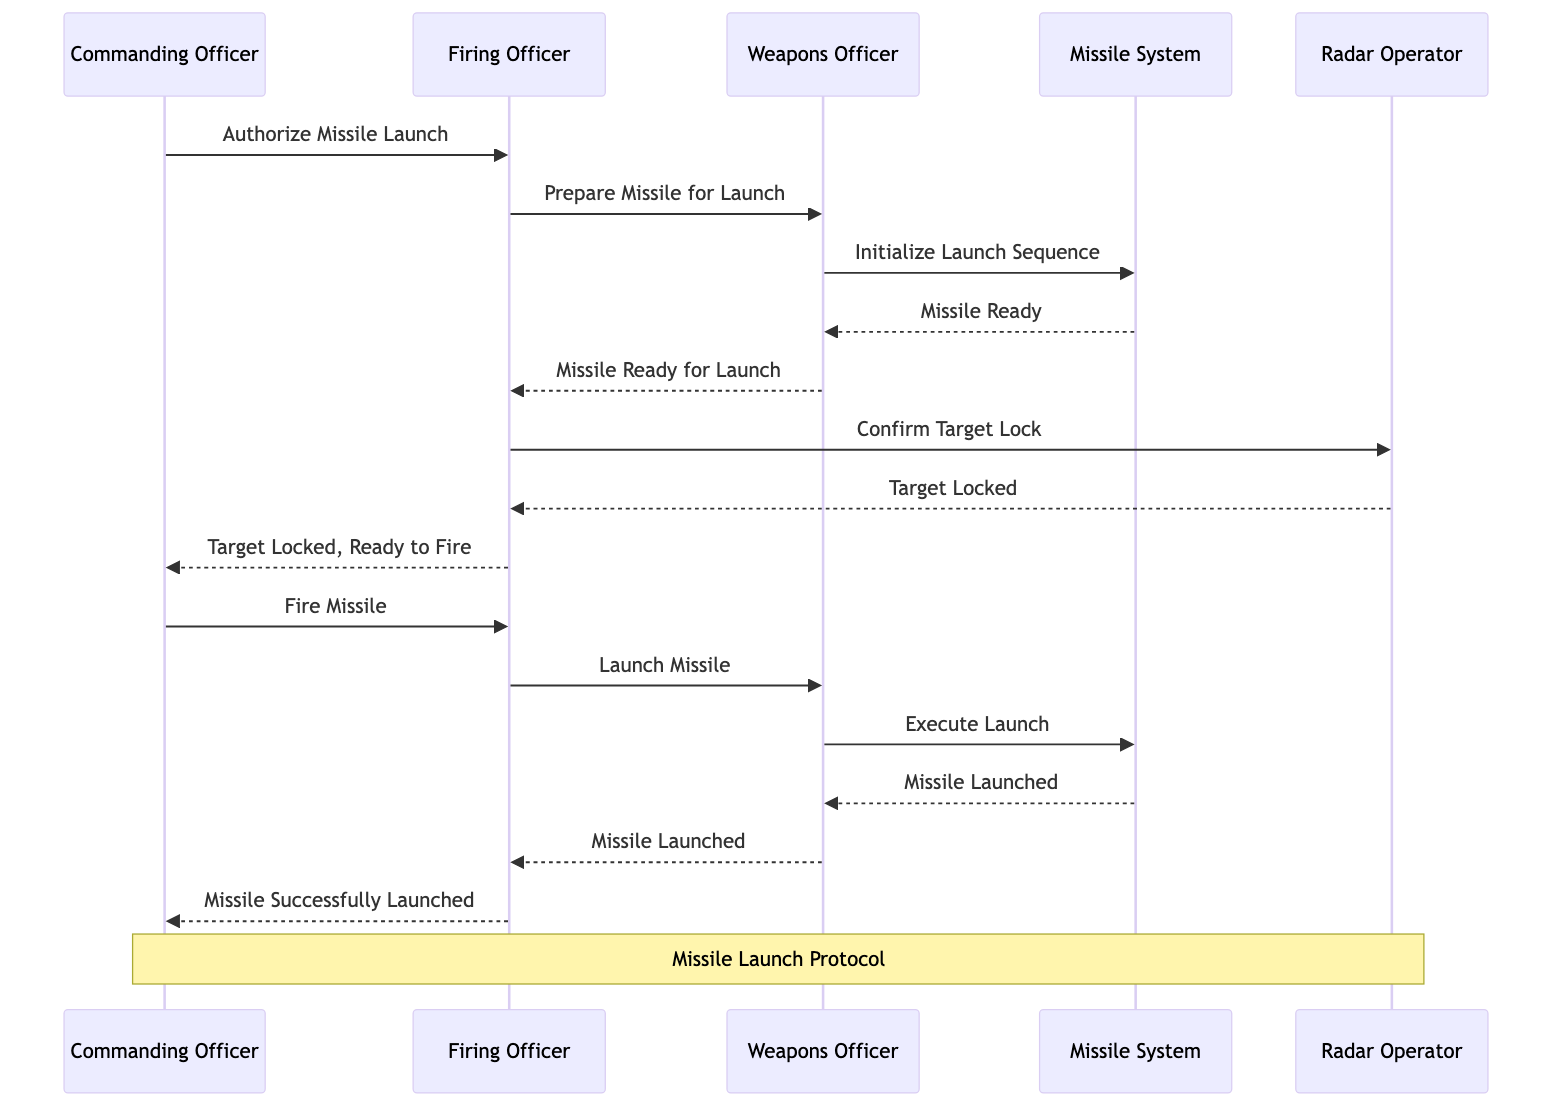What is the first command issued in the sequence? The sequence begins with the Commanding Officer issuing a command to the Firing Officer with the message "Authorize Missile Launch." This initiates the protocol.
Answer: Authorize Missile Launch How many officers are involved in the missile launch protocol? The diagram includes three officers: the Commanding Officer, the Firing Officer, and the Weapons Officer. Each has a distinct role in the launching process, making a total of three.
Answer: 3 Which actor confirms the target lock? The Firing Officer sends a signal to the Radar Operator to confirm the target lock. The Radar Operator responds back with "Target Locked." Thus, the Radar Operator is the one who confirms the target lock.
Answer: Radar Operator What message does the Firing Officer send after receiving confirmation of the target lock? After the target lock is confirmed, the Firing Officer notifies the Commanding Officer with the message "Target Locked, Ready to Fire." This indicates that the necessary steps have been completed for launching the missile.
Answer: Target Locked, Ready to Fire What happens immediately after the Firing Officer issues the command to launch the missile? The Firing Officer instructs the Weapons Officer to "Launch Missile," which is followed by the Weapons Officer signaling the Missile System to execute the launch. This means that the command initiates the launch sequence in the Missile System.
Answer: Execute Launch What is the final notification from the Firing Officer? The last notification from the Firing Officer to the Commanding Officer states "Missile Successfully Launched," indicating the completion of the missile launch protocol successfully. This signal concludes the sequence between the officers.
Answer: Missile Successfully Launched How many messages are sent from the Weapons Officer to the Missile System? The Weapons Officer sends two messages to the Missile System: "Initialize Launch Sequence" and "Execute Launch." This indicates there are two distinct interactions between these two actors.
Answer: 2 Who initiates the preparation for the missile launch? The Firing Officer initiates the preparation by sending a command to the Weapons Officer with the message "Prepare Missile for Launch." This step is essential for the subsequent actions within the launch protocol.
Answer: Firing Officer What is the last action taken by the Missile System in this sequence? The last action taken by the Missile System is to notify the Weapons Officer with the message "Missile Launched," which confirms the successful launch of the missile from the system's perspective.
Answer: Missile Launched 